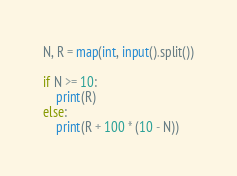<code> <loc_0><loc_0><loc_500><loc_500><_Python_>N, R = map(int, input().split())

if N >= 10:
    print(R)
else:
    print(R + 100 * (10 - N))</code> 